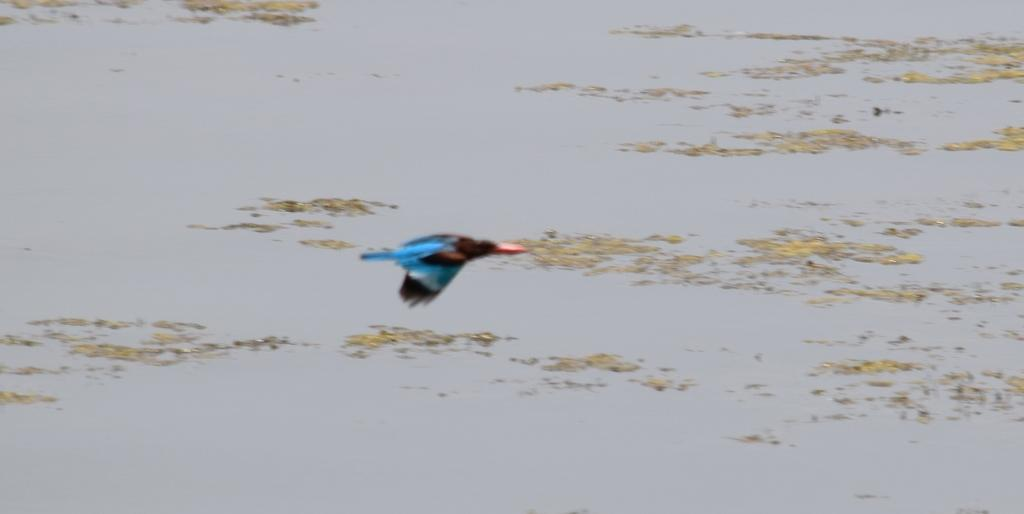What is the main subject of the image? The main subject of the image is a flying bird. What can be seen in the background of the image? There is water visible in the image. What type of fiction is the bird reading in the image? There is no indication in the image that the bird is reading any fiction, as birds do not read. 